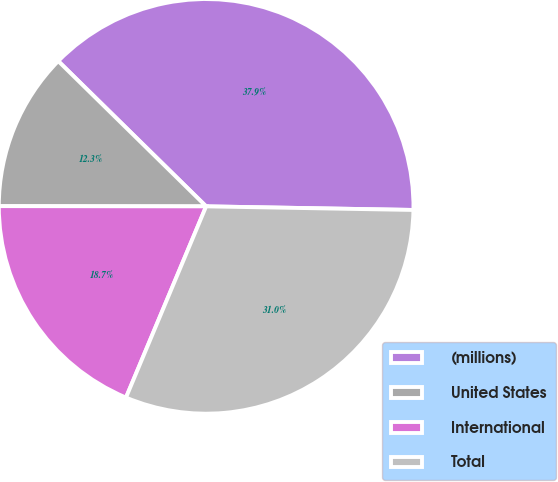Convert chart to OTSL. <chart><loc_0><loc_0><loc_500><loc_500><pie_chart><fcel>(millions)<fcel>United States<fcel>International<fcel>Total<nl><fcel>37.92%<fcel>12.34%<fcel>18.7%<fcel>31.04%<nl></chart> 